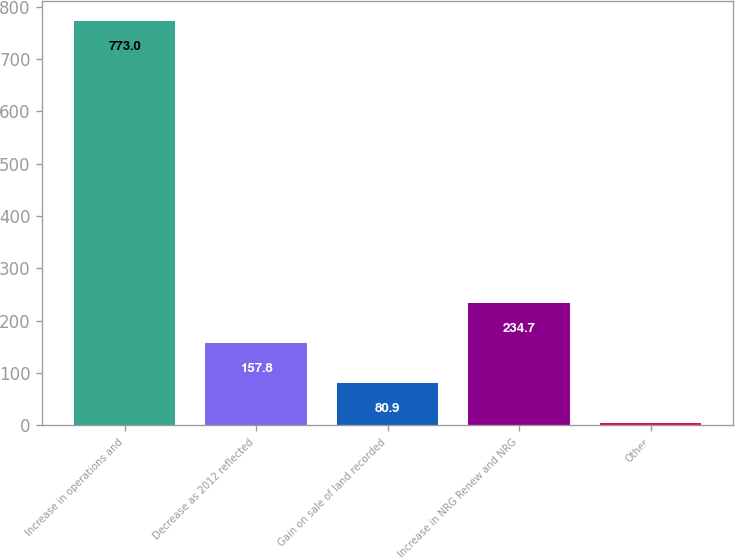<chart> <loc_0><loc_0><loc_500><loc_500><bar_chart><fcel>Increase in operations and<fcel>Decrease as 2012 reflected<fcel>Gain on sale of land recorded<fcel>Increase in NRG Renew and NRG<fcel>Other<nl><fcel>773<fcel>157.8<fcel>80.9<fcel>234.7<fcel>4<nl></chart> 